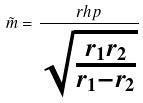Convert formula to latex. <formula><loc_0><loc_0><loc_500><loc_500>\tilde { m } = \frac { r h p } { \sqrt { \frac { r _ { 1 } r _ { 2 } } { r _ { 1 } - r _ { 2 } } } }</formula> 